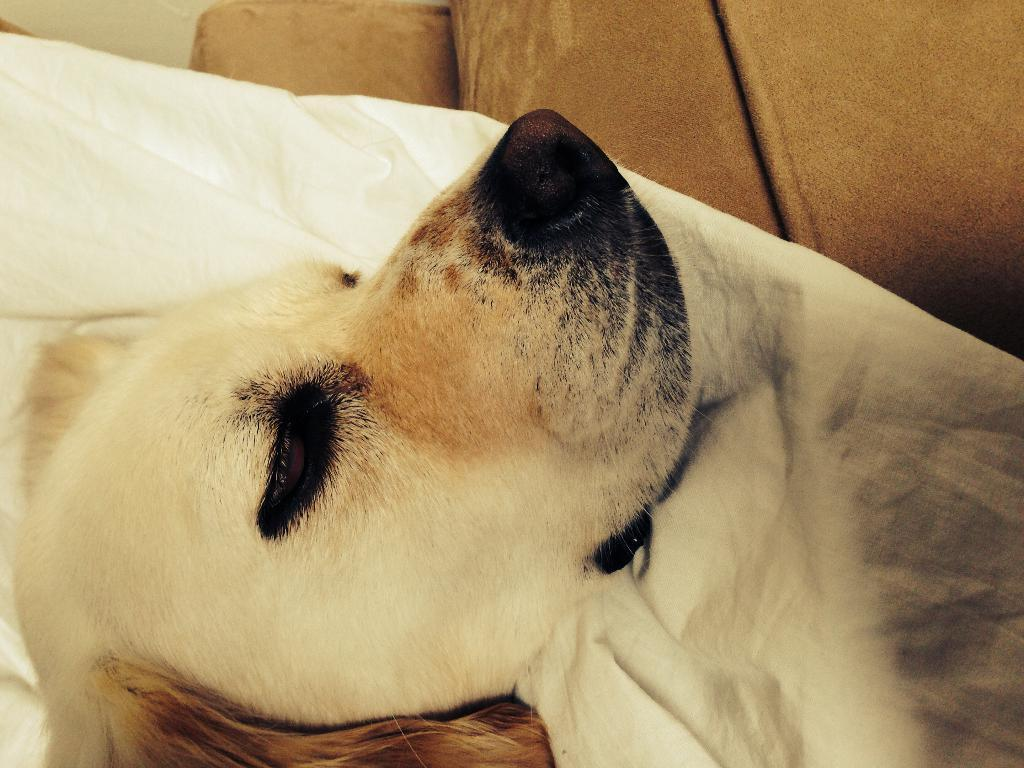What type of animal is in the image? There is a dog in the image. Can you describe the dog's appearance? The dog is cream-colored. What can be seen in the background of the image? There is a brown-colored sofa in the background of the image. Where is the goldfish swimming in the image? There is no goldfish present in the image. What type of books can be found in the library depicted in the image? There is no library present in the image. 